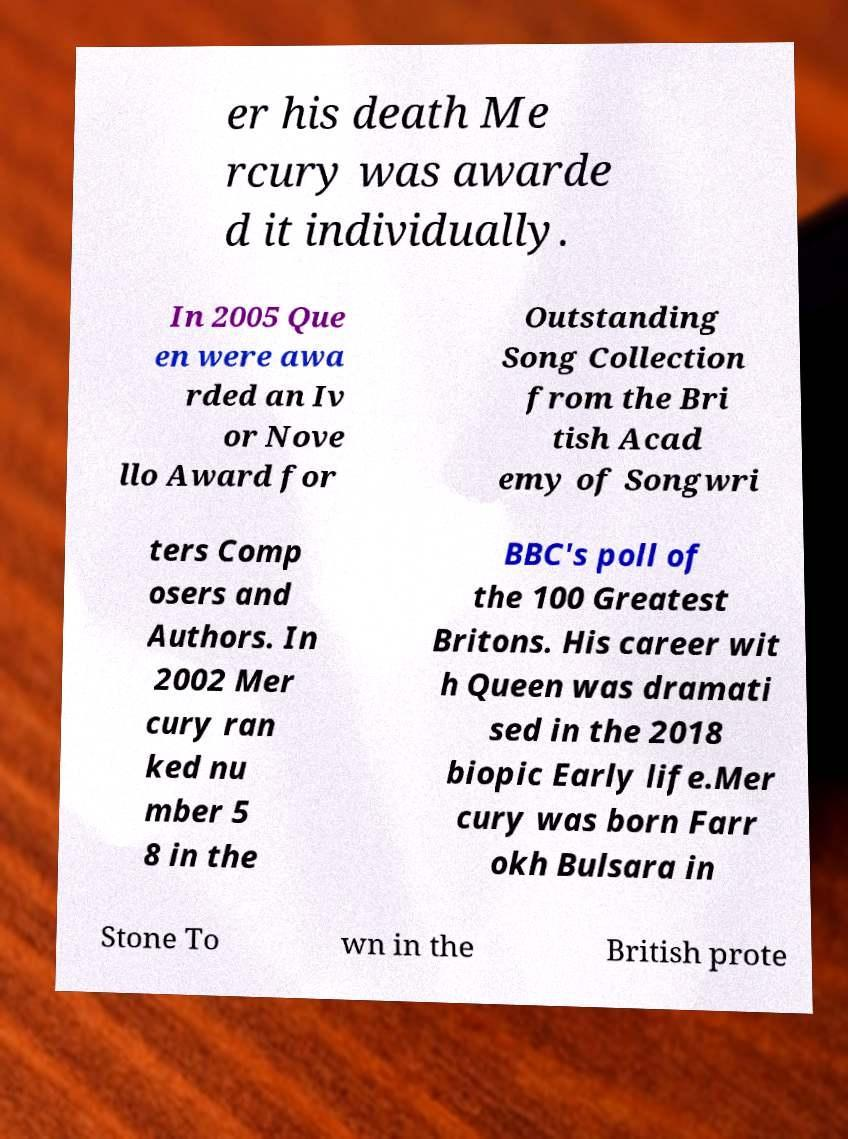Can you read and provide the text displayed in the image?This photo seems to have some interesting text. Can you extract and type it out for me? er his death Me rcury was awarde d it individually. In 2005 Que en were awa rded an Iv or Nove llo Award for Outstanding Song Collection from the Bri tish Acad emy of Songwri ters Comp osers and Authors. In 2002 Mer cury ran ked nu mber 5 8 in the BBC's poll of the 100 Greatest Britons. His career wit h Queen was dramati sed in the 2018 biopic Early life.Mer cury was born Farr okh Bulsara in Stone To wn in the British prote 